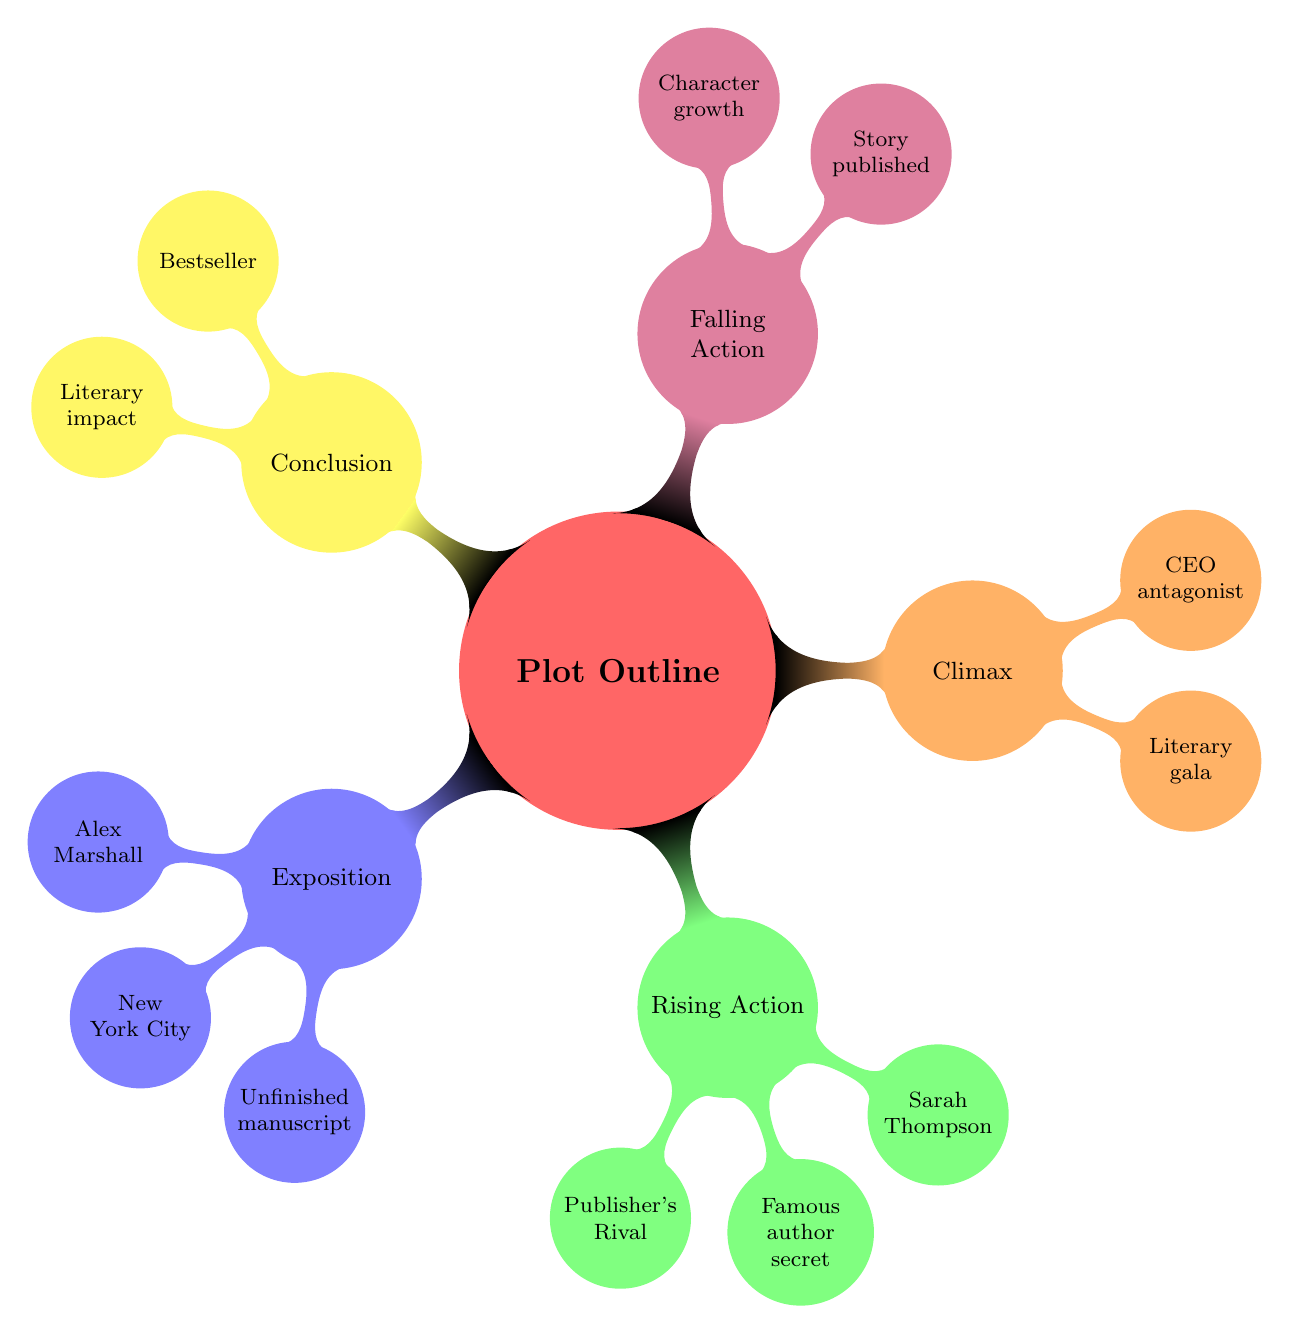What is the protagonist's name? The name of the protagonist is mentioned in the Exposition section of the diagram. It states "Alex Marshall."
Answer: Alex Marshall How many main sections are in the plot outline? Counting the major categories, we can identify five sections: Exposition, Rising Action, Climax, Falling Action, and Conclusion.
Answer: 5 What key event occurs in the Rising Action? Within the Rising Action section, a significant conflict is introduced, specifically the "Conflict with Antagonist," which mentions the Publisher's Rival Company.
Answer: Publisher's Rival What is the setting of the story? The Setting node explicitly states "New York City," which identifies where the story takes place.
Answer: New York City What happens during the Climax? The Climax section describes two important confrontations: a "Showdown" at a literary gala and the "Critical Revelation" of the CEO's true nature as the antagonist.
Answer: Literary gala What leads to the resolution of conflict? Within the Falling Action, it is stated that the "Rival company collapses," which is a pivotal event leading to the resolution of conflict in the story.
Answer: Rival company collapses How does Alex grow as a character? The Falling Action specifies "Character Growth," indicating that Alex learns the importance of integrity in writing throughout the story.
Answer: Integrity in writing What is the final outcome for Alex's story? In the Conclusion, it states that Alex's story becomes a "bestseller," which signifies a successful outcome following the events of the plot.
Answer: Bestseller What is the impact mentioned in the Conclusion? The Conclusion node highlights "Impact on New York's literary community," illustrating the broader effects of Alex's success.
Answer: Literary impact 